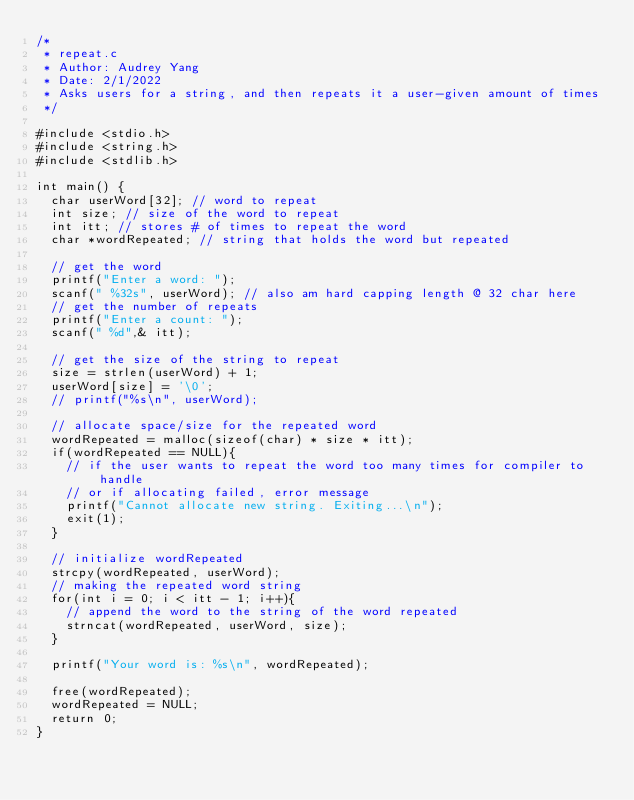<code> <loc_0><loc_0><loc_500><loc_500><_C_>/*
 * repeat.c
 * Author: Audrey Yang
 * Date: 2/1/2022
 * Asks users for a string, and then repeats it a user-given amount of times
 */

#include <stdio.h>
#include <string.h>
#include <stdlib.h>

int main() {
  char userWord[32]; // word to repeat
  int size; // size of the word to repeat
  int itt; // stores # of times to repeat the word
  char *wordRepeated; // string that holds the word but repeated

  // get the word
  printf("Enter a word: ");
  scanf(" %32s", userWord); // also am hard capping length @ 32 char here
  // get the number of repeats
  printf("Enter a count: ");
  scanf(" %d",& itt);
  
  // get the size of the string to repeat
  size = strlen(userWord) + 1;
  userWord[size] = '\0';
  // printf("%s\n", userWord);

  // allocate space/size for the repeated word
  wordRepeated = malloc(sizeof(char) * size * itt); 
  if(wordRepeated == NULL){ 
    // if the user wants to repeat the word too many times for compiler to handle
    // or if allocating failed, error message
    printf("Cannot allocate new string. Exiting...\n");
    exit(1);
  }

  // initialize wordRepeated
  strcpy(wordRepeated, userWord);
  // making the repeated word string
  for(int i = 0; i < itt - 1; i++){
    // append the word to the string of the word repeated
    strncat(wordRepeated, userWord, size); 
  }
  
  printf("Your word is: %s\n", wordRepeated);

  free(wordRepeated);
  wordRepeated = NULL;
  return 0;
}
</code> 